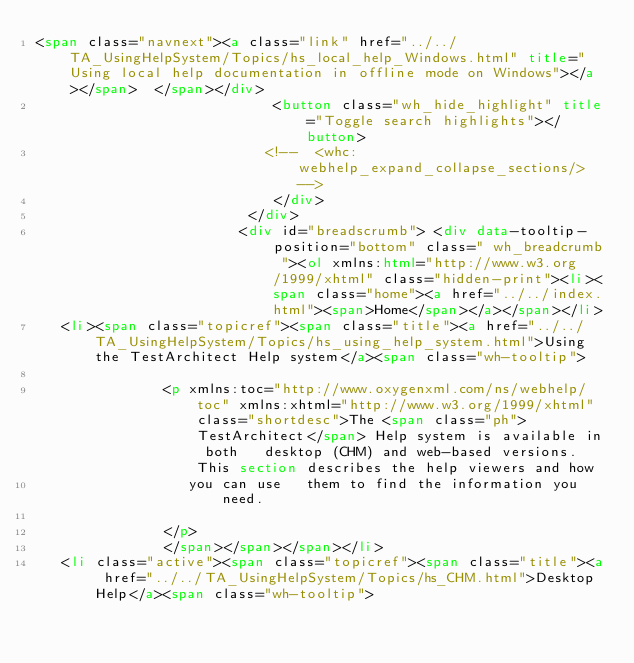<code> <loc_0><loc_0><loc_500><loc_500><_HTML_><span class="navnext"><a class="link" href="../../TA_UsingHelpSystem/Topics/hs_local_help_Windows.html" title="Using local help documentation in offline mode on Windows"></a></span>  </span></div>
                            <button class="wh_hide_highlight" title="Toggle search highlights"></button>
                           <!--  <whc:webhelp_expand_collapse_sections/> -->
                            </div>
                         </div>
                        <div id="breadscrumb"> <div data-tooltip-position="bottom" class=" wh_breadcrumb "><ol xmlns:html="http://www.w3.org/1999/xhtml" class="hidden-print"><li><span class="home"><a href="../../index.html"><span>Home</span></a></span></li>
   <li><span class="topicref"><span class="title"><a href="../../TA_UsingHelpSystem/Topics/hs_using_help_system.html">Using the TestArchitect Help system</a><span class="wh-tooltip">
               
               <p xmlns:toc="http://www.oxygenxml.com/ns/webhelp/toc" xmlns:xhtml="http://www.w3.org/1999/xhtml" class="shortdesc">The <span class="ph">TestArchitect</span> Help system is available in both   desktop (CHM) and web-based versions. This section describes the help viewers and how
                  you can use   them to find the information you need.
                  
               </p>
               </span></span></span></li>
   <li class="active"><span class="topicref"><span class="title"><a href="../../TA_UsingHelpSystem/Topics/hs_CHM.html">Desktop Help</a><span class="wh-tooltip">
               </code> 